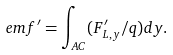Convert formula to latex. <formula><loc_0><loc_0><loc_500><loc_500>e m f ^ { \prime } = \int _ { A C } ( F _ { L , y } ^ { \prime } / q ) d y .</formula> 